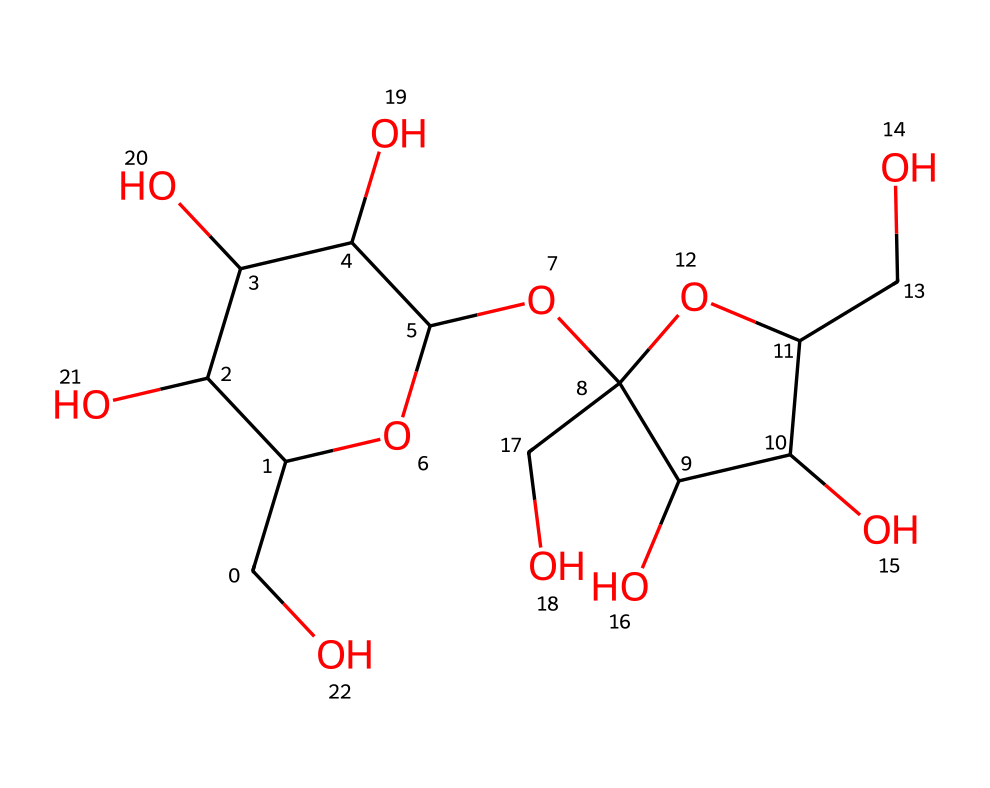What is the molecular formula of sucrose? To determine the molecular formula from the SMILES representation, we count the number of each type of atom in the structure. The structure contains: 12 carbon (C), 22 hydrogen (H), and 11 oxygen (O) atoms. Thus, the molecular formula is C12H22O11.
Answer: C12H22O11 How many rings are present in the structure of sucrose? By analyzing the structure, we see two cyclic components, which can be observed from the "C1" and "C2" in the SMILES, indicating that there are two rings where two anomeric carbons are present in each ring.
Answer: 2 What type of carbohydrate is sucrose classified as? Sucrose is formed from the combination of two monosaccharides: glucose and fructose. Since it consists of two sugar units, it is classified as a disaccharide.
Answer: disaccharide How many hydroxyl groups are in sucrose? By examining the structure closely, we note that hydroxyl groups (–OH) are present on several carbons in the sugar rings and the linkage. Counting these, we find a total of 8 hydroxyl groups in the structure.
Answer: 8 What role does sucrose play in cognitive enhancement? Sucrose can provide a quick source of energy for the brain and may help improve cognitive functions, especially during intense focus tasks. This quick energy source can benefit professionals needing sustained attention, like cybersecurity experts.
Answer: energy source 